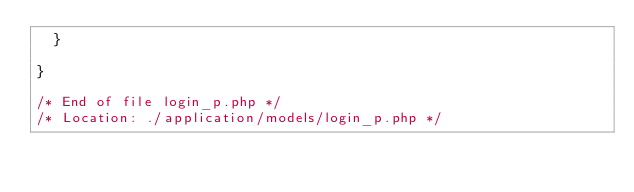Convert code to text. <code><loc_0><loc_0><loc_500><loc_500><_PHP_>	}

}

/* End of file login_p.php */
/* Location: ./application/models/login_p.php */</code> 